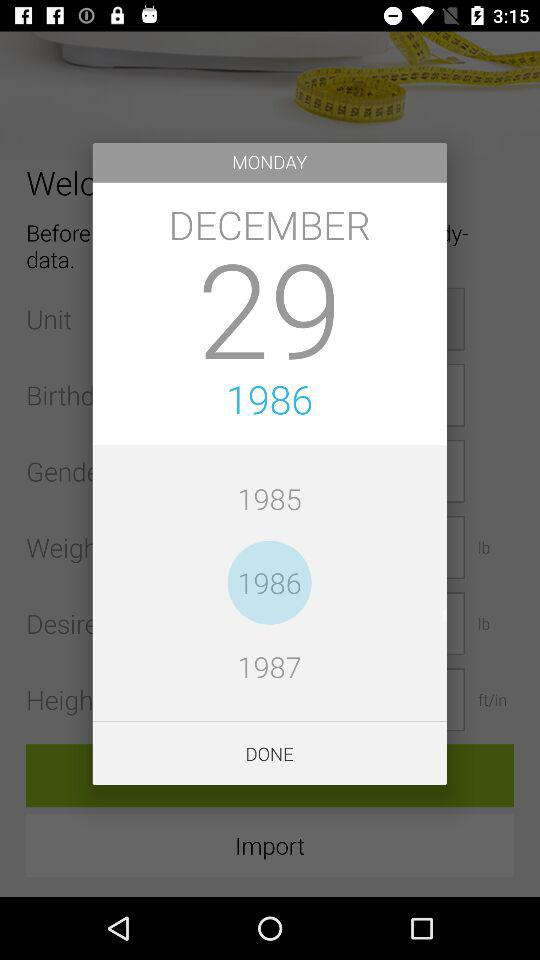Which date is selected? The selected date is Monday, December 29, 1986. 